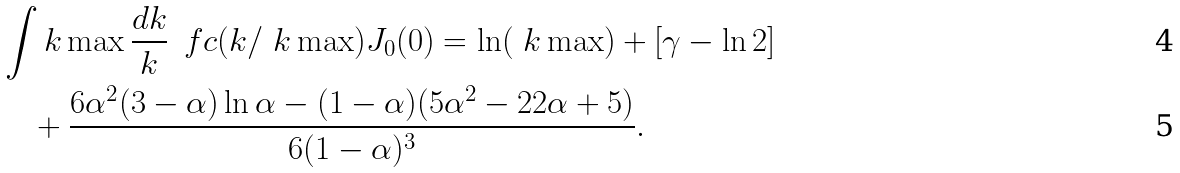Convert formula to latex. <formula><loc_0><loc_0><loc_500><loc_500>& \int k \max \frac { d k } { k } \, \ f c ( k / \ k \max ) J _ { 0 } ( 0 ) = \ln ( \ k \max ) + [ \gamma - \ln 2 ] \\ & \quad + \frac { 6 \alpha ^ { 2 } ( 3 - \alpha ) \ln \alpha - ( 1 - \alpha ) ( 5 \alpha ^ { 2 } - 2 2 \alpha + 5 ) } { 6 ( 1 - \alpha ) ^ { 3 } } .</formula> 